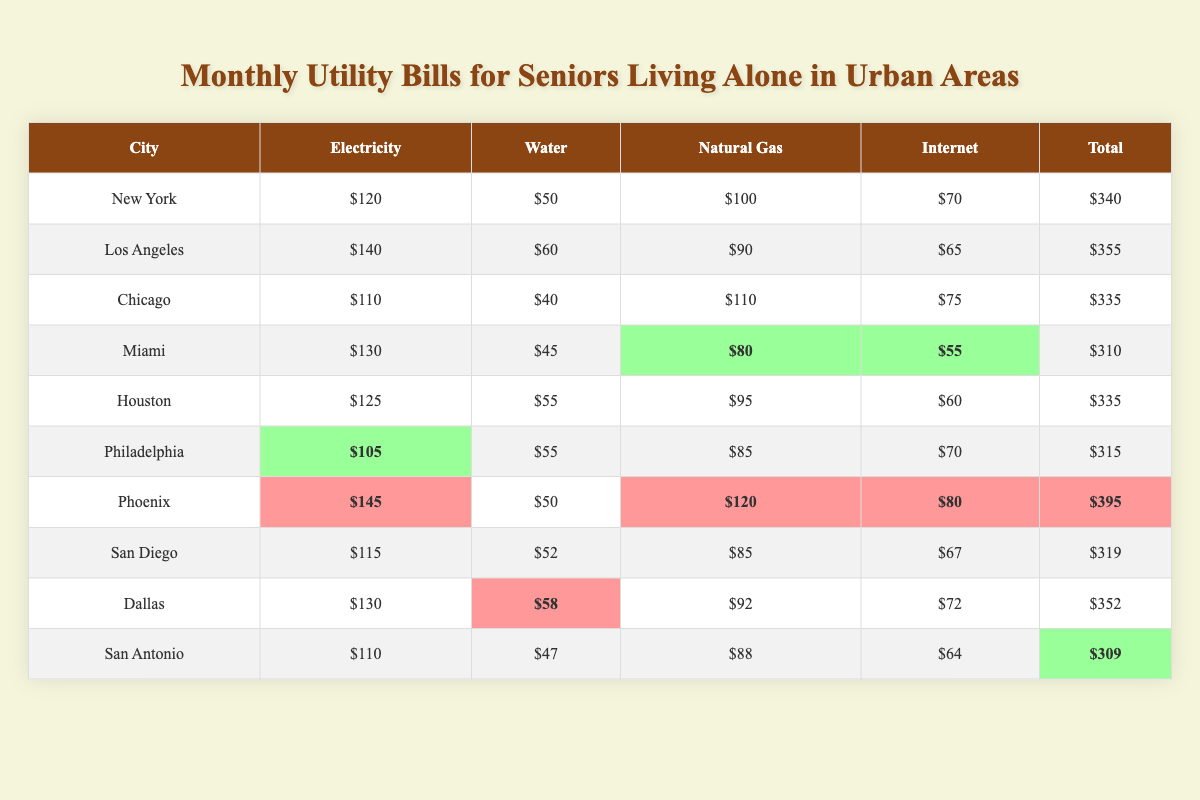What's the total utility bill cost for seniors in Miami? The total utility bill cost for Miami is listed in the table as $310.
Answer: $310 Which city has the highest electricity cost? The electricity cost for each city is compared, and Phoenix has the highest cost at $145.
Answer: Phoenix What is the average total bill across all cities? To calculate the average, sum all total bills: (340 + 355 + 335 + 310 + 335 + 315 + 395 + 319 + 352 + 309) = 3445. Then divide by the number of cities (10): 3445 / 10 = 344.5.
Answer: 344.5 Is the total utility bill in Philadelphia higher than in San Antonio? The total utility bill for Philadelphia is $315 and for San Antonio is $309. Since $315 is greater than $309, the answer is yes.
Answer: Yes What is the total cost of water for all cities? The total water cost is the sum of the water costs for each city: (50 + 60 + 40 + 45 + 55 + 55 + 50 + 52 + 58 + 47) = 462.
Answer: 462 Which city has the lowest natural gas bill? The table shows that Miami has the lowest natural gas bill at $80.
Answer: Miami How much more does Phoenix spend on the internet compared to Miami? The internet cost in Phoenix is $80, and in Miami it is $55. To find the difference: $80 - $55 = $25.
Answer: $25 What percentage of the total bill in New York is spent on electricity? The total bill in New York is $340, and the electricity cost is $120. The percentage is calculated as ($120 / $340) * 100 = 35.29%.
Answer: 35.29% How does the total utility bill of Dallas compare with that of Chicago? Dallas has a total bill of $352, while Chicago has $335. Since $352 is greater than $335, Dallas's total is higher.
Answer: Dallas is higher Which city has the lowest total utility bill and what is the amount? The lowest total utility bill is in San Antonio at $309, as indicated in the table.
Answer: San Antonio, $309 